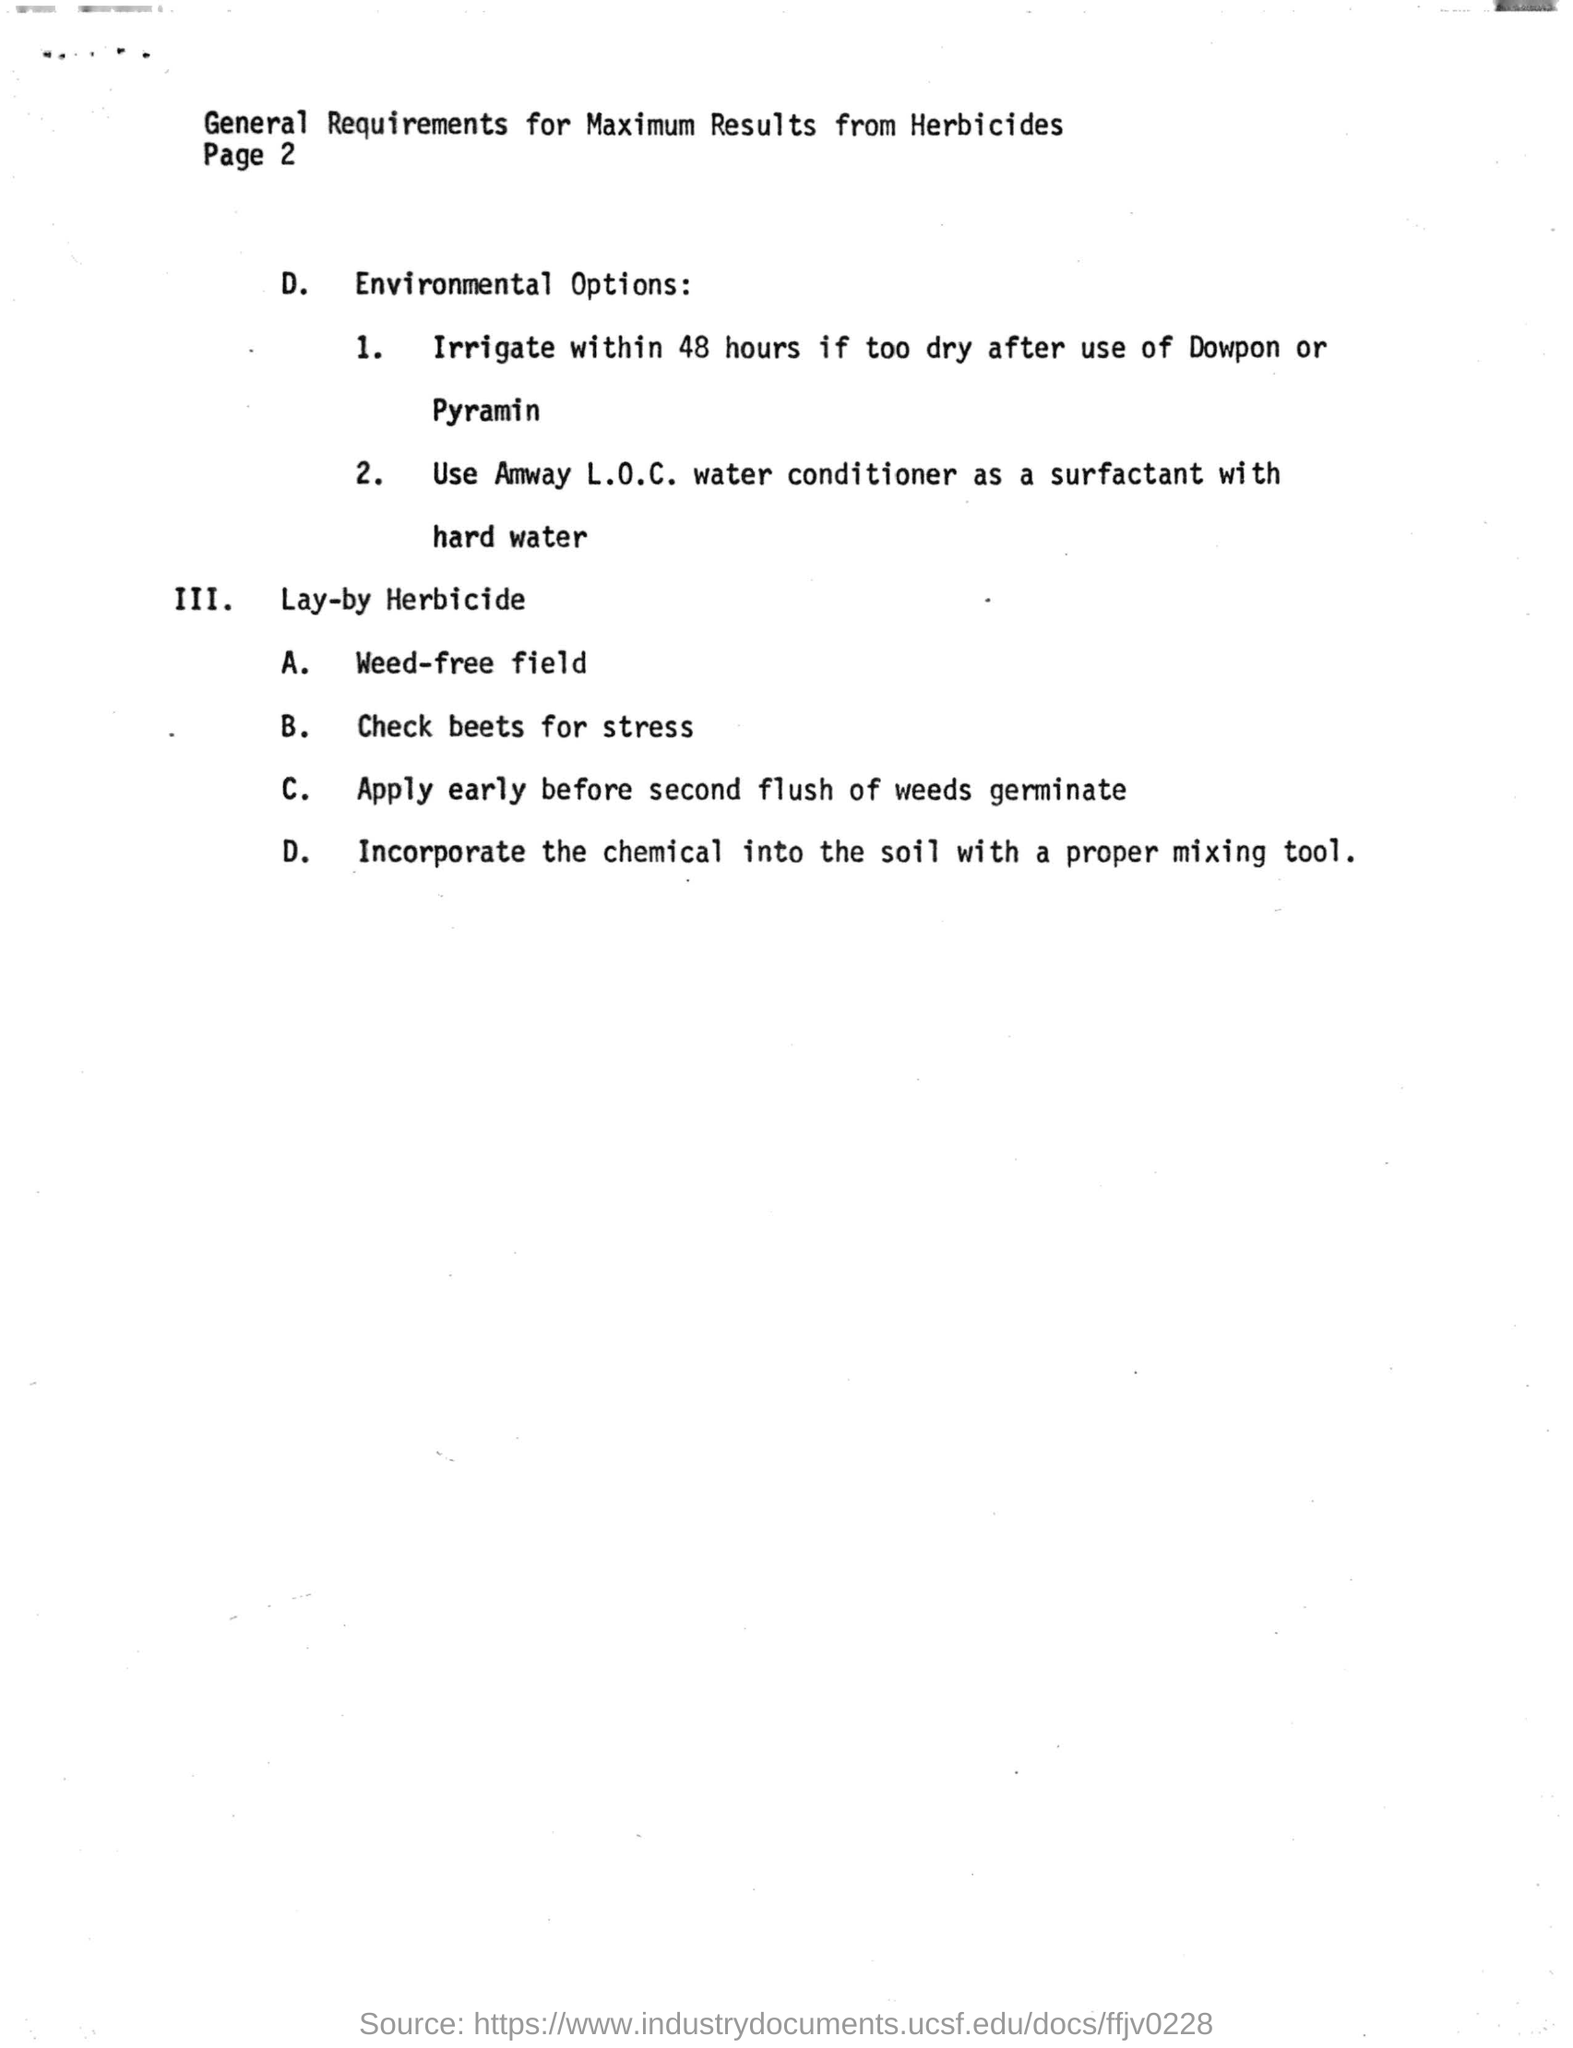Which water conditioner is used as surfactant with hard water
Keep it short and to the point. Amway L.O.C. How many environmental options are listed?
Make the answer very short. 2. 